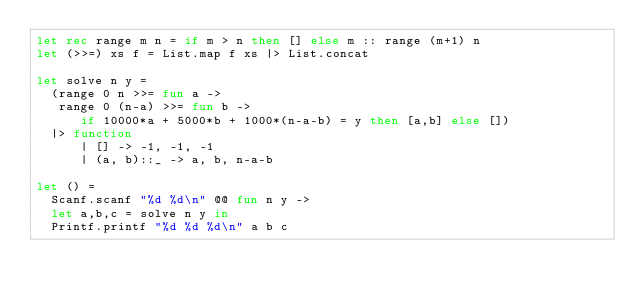<code> <loc_0><loc_0><loc_500><loc_500><_OCaml_>let rec range m n = if m > n then [] else m :: range (m+1) n
let (>>=) xs f = List.map f xs |> List.concat

let solve n y =
  (range 0 n >>= fun a ->
   range 0 (n-a) >>= fun b ->
      if 10000*a + 5000*b + 1000*(n-a-b) = y then [a,b] else [])
  |> function
      | [] -> -1, -1, -1
      | (a, b)::_ -> a, b, n-a-b

let () =
  Scanf.scanf "%d %d\n" @@ fun n y ->
  let a,b,c = solve n y in
  Printf.printf "%d %d %d\n" a b c</code> 